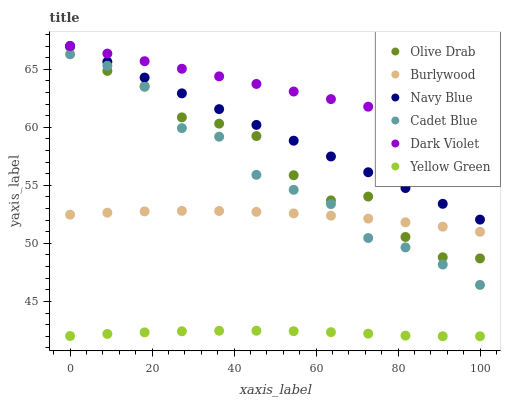Does Yellow Green have the minimum area under the curve?
Answer yes or no. Yes. Does Dark Violet have the maximum area under the curve?
Answer yes or no. Yes. Does Burlywood have the minimum area under the curve?
Answer yes or no. No. Does Burlywood have the maximum area under the curve?
Answer yes or no. No. Is Dark Violet the smoothest?
Answer yes or no. Yes. Is Olive Drab the roughest?
Answer yes or no. Yes. Is Yellow Green the smoothest?
Answer yes or no. No. Is Yellow Green the roughest?
Answer yes or no. No. Does Yellow Green have the lowest value?
Answer yes or no. Yes. Does Burlywood have the lowest value?
Answer yes or no. No. Does Dark Violet have the highest value?
Answer yes or no. Yes. Does Burlywood have the highest value?
Answer yes or no. No. Is Yellow Green less than Burlywood?
Answer yes or no. Yes. Is Dark Violet greater than Olive Drab?
Answer yes or no. Yes. Does Burlywood intersect Cadet Blue?
Answer yes or no. Yes. Is Burlywood less than Cadet Blue?
Answer yes or no. No. Is Burlywood greater than Cadet Blue?
Answer yes or no. No. Does Yellow Green intersect Burlywood?
Answer yes or no. No. 